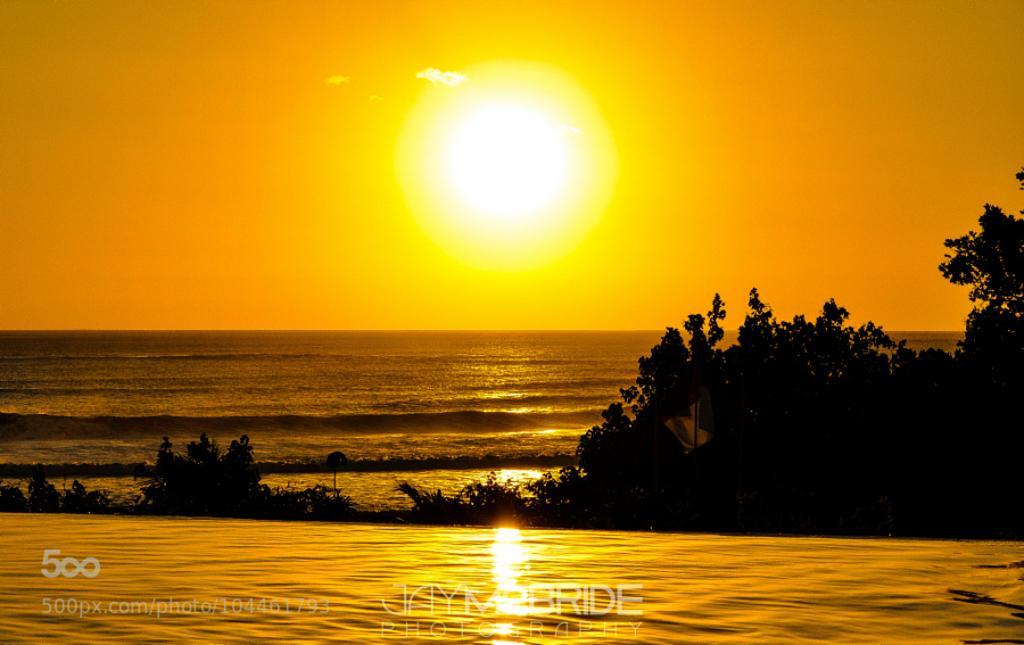Could you give a brief overview of what you see in this image? In this image we can see a few trees and the water, in the background, we can see the sunlight and the sky, at the bottom of the image we can see the text. 